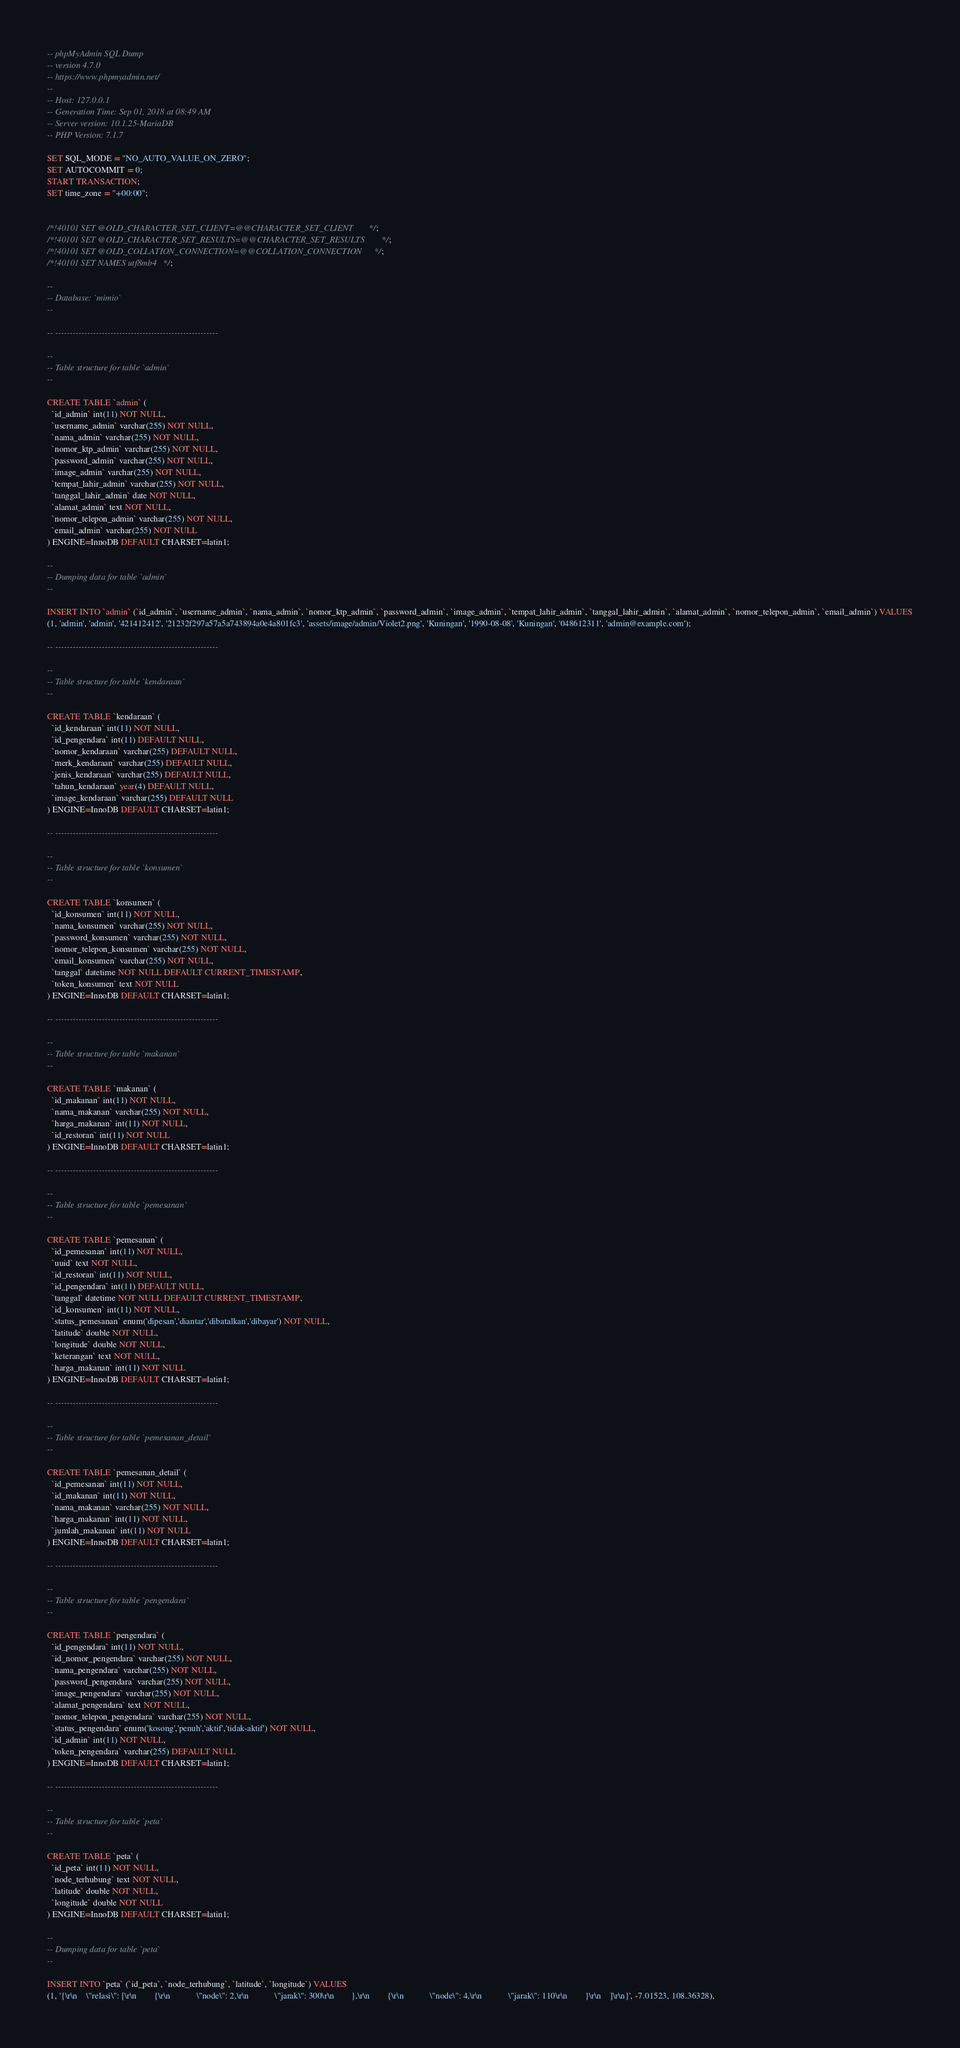Convert code to text. <code><loc_0><loc_0><loc_500><loc_500><_SQL_>-- phpMyAdmin SQL Dump
-- version 4.7.0
-- https://www.phpmyadmin.net/
--
-- Host: 127.0.0.1
-- Generation Time: Sep 01, 2018 at 08:49 AM
-- Server version: 10.1.25-MariaDB
-- PHP Version: 7.1.7

SET SQL_MODE = "NO_AUTO_VALUE_ON_ZERO";
SET AUTOCOMMIT = 0;
START TRANSACTION;
SET time_zone = "+00:00";


/*!40101 SET @OLD_CHARACTER_SET_CLIENT=@@CHARACTER_SET_CLIENT */;
/*!40101 SET @OLD_CHARACTER_SET_RESULTS=@@CHARACTER_SET_RESULTS */;
/*!40101 SET @OLD_COLLATION_CONNECTION=@@COLLATION_CONNECTION */;
/*!40101 SET NAMES utf8mb4 */;

--
-- Database: `mimio`
--

-- --------------------------------------------------------

--
-- Table structure for table `admin`
--

CREATE TABLE `admin` (
  `id_admin` int(11) NOT NULL,
  `username_admin` varchar(255) NOT NULL,
  `nama_admin` varchar(255) NOT NULL,
  `nomor_ktp_admin` varchar(255) NOT NULL,
  `password_admin` varchar(255) NOT NULL,
  `image_admin` varchar(255) NOT NULL,
  `tempat_lahir_admin` varchar(255) NOT NULL,
  `tanggal_lahir_admin` date NOT NULL,
  `alamat_admin` text NOT NULL,
  `nomor_telepon_admin` varchar(255) NOT NULL,
  `email_admin` varchar(255) NOT NULL
) ENGINE=InnoDB DEFAULT CHARSET=latin1;

--
-- Dumping data for table `admin`
--

INSERT INTO `admin` (`id_admin`, `username_admin`, `nama_admin`, `nomor_ktp_admin`, `password_admin`, `image_admin`, `tempat_lahir_admin`, `tanggal_lahir_admin`, `alamat_admin`, `nomor_telepon_admin`, `email_admin`) VALUES
(1, 'admin', 'admin', '421412412', '21232f297a57a5a743894a0e4a801fc3', 'assets/image/admin/Violet2.png', 'Kuningan', '1990-08-08', 'Kuningan', '048612311', 'admin@example.com');

-- --------------------------------------------------------

--
-- Table structure for table `kendaraan`
--

CREATE TABLE `kendaraan` (
  `id_kendaraan` int(11) NOT NULL,
  `id_pengendara` int(11) DEFAULT NULL,
  `nomor_kendaraan` varchar(255) DEFAULT NULL,
  `merk_kendaraan` varchar(255) DEFAULT NULL,
  `jenis_kendaraan` varchar(255) DEFAULT NULL,
  `tahun_kendaraan` year(4) DEFAULT NULL,
  `image_kendaraan` varchar(255) DEFAULT NULL
) ENGINE=InnoDB DEFAULT CHARSET=latin1;

-- --------------------------------------------------------

--
-- Table structure for table `konsumen`
--

CREATE TABLE `konsumen` (
  `id_konsumen` int(11) NOT NULL,
  `nama_konsumen` varchar(255) NOT NULL,
  `password_konsumen` varchar(255) NOT NULL,
  `nomor_telepon_konsumen` varchar(255) NOT NULL,
  `email_konsumen` varchar(255) NOT NULL,
  `tanggal` datetime NOT NULL DEFAULT CURRENT_TIMESTAMP,
  `token_konsumen` text NOT NULL
) ENGINE=InnoDB DEFAULT CHARSET=latin1;

-- --------------------------------------------------------

--
-- Table structure for table `makanan`
--

CREATE TABLE `makanan` (
  `id_makanan` int(11) NOT NULL,
  `nama_makanan` varchar(255) NOT NULL,
  `harga_makanan` int(11) NOT NULL,
  `id_restoran` int(11) NOT NULL
) ENGINE=InnoDB DEFAULT CHARSET=latin1;

-- --------------------------------------------------------

--
-- Table structure for table `pemesanan`
--

CREATE TABLE `pemesanan` (
  `id_pemesanan` int(11) NOT NULL,
  `uuid` text NOT NULL,
  `id_restoran` int(11) NOT NULL,
  `id_pengendara` int(11) DEFAULT NULL,
  `tanggal` datetime NOT NULL DEFAULT CURRENT_TIMESTAMP,
  `id_konsumen` int(11) NOT NULL,
  `status_pemesanan` enum('dipesan','diantar','dibatalkan','dibayar') NOT NULL,
  `latitude` double NOT NULL,
  `longitude` double NOT NULL,
  `keterangan` text NOT NULL,
  `harga_makanan` int(11) NOT NULL
) ENGINE=InnoDB DEFAULT CHARSET=latin1;

-- --------------------------------------------------------

--
-- Table structure for table `pemesanan_detail`
--

CREATE TABLE `pemesanan_detail` (
  `id_pemesanan` int(11) NOT NULL,
  `id_makanan` int(11) NOT NULL,
  `nama_makanan` varchar(255) NOT NULL,
  `harga_makanan` int(11) NOT NULL,
  `jumlah_makanan` int(11) NOT NULL
) ENGINE=InnoDB DEFAULT CHARSET=latin1;

-- --------------------------------------------------------

--
-- Table structure for table `pengendara`
--

CREATE TABLE `pengendara` (
  `id_pengendara` int(11) NOT NULL,
  `id_nomor_pengendara` varchar(255) NOT NULL,
  `nama_pengendara` varchar(255) NOT NULL,
  `password_pengendara` varchar(255) NOT NULL,
  `image_pengendara` varchar(255) NOT NULL,
  `alamat_pengendara` text NOT NULL,
  `nomor_telepon_pengendara` varchar(255) NOT NULL,
  `status_pengendara` enum('kosong','penuh','aktif','tidak-aktif') NOT NULL,
  `id_admin` int(11) NOT NULL,
  `token_pengendara` varchar(255) DEFAULT NULL
) ENGINE=InnoDB DEFAULT CHARSET=latin1;

-- --------------------------------------------------------

--
-- Table structure for table `peta`
--

CREATE TABLE `peta` (
  `id_peta` int(11) NOT NULL,
  `node_terhubung` text NOT NULL,
  `latitude` double NOT NULL,
  `longitude` double NOT NULL
) ENGINE=InnoDB DEFAULT CHARSET=latin1;

--
-- Dumping data for table `peta`
--

INSERT INTO `peta` (`id_peta`, `node_terhubung`, `latitude`, `longitude`) VALUES
(1, '{\r\n    \"relasi\": [\r\n        {\r\n            \"node\": 2,\r\n            \"jarak\": 300\r\n        },\r\n        {\r\n            \"node\": 4,\r\n            \"jarak\": 110\r\n        }\r\n    ]\r\n}', -7.01523, 108.36328),</code> 